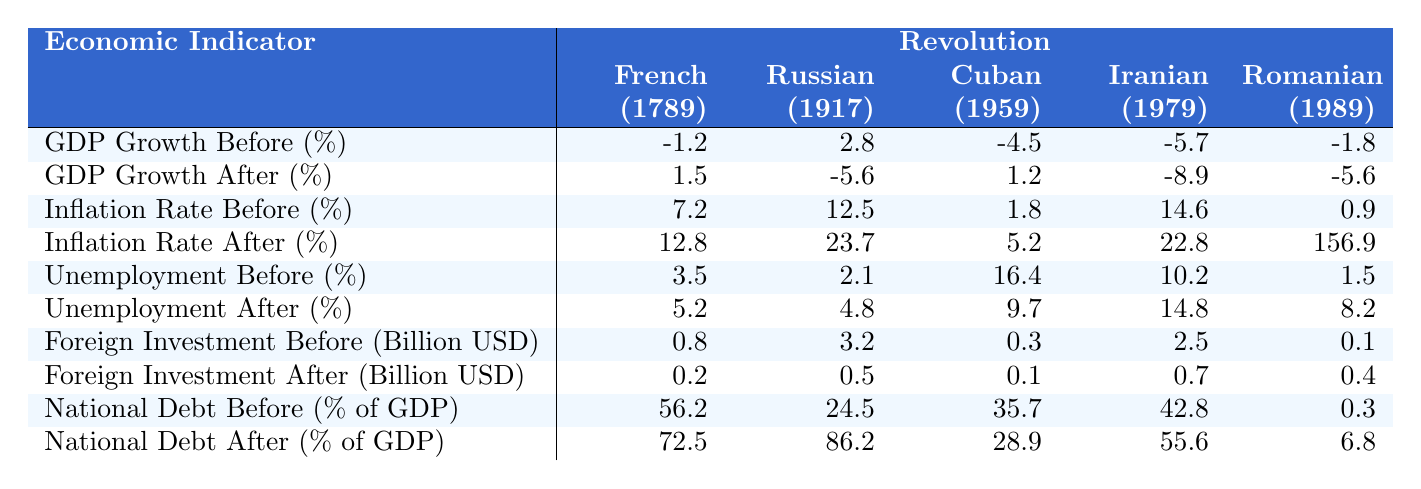What was the unemployment rate before the Cuban Revolution? The unemployment rate data for the Cuban Revolution (1959) is listed as 16.4%.
Answer: 16.4% What is the difference in GDP growth rates before and after the Iranian Revolution? For the Iranian Revolution (1979), GDP growth was -5.7% before and -8.9% after. The difference is calculated as -8.9 - (-5.7) = -3.2%.
Answer: -3.2% Was the inflation rate higher after the Romanian Revolution compared to before? The inflation rate before the Romanian Revolution (1989) was 0.9%, while after it was 156.9%. Since 156.9% is greater than 0.9%, the statement is true.
Answer: Yes Which revolution saw the highest increase in the national debt as a percentage of GDP? Examining the national debt before and after each revolution, the highest increase is from the Russian Revolution: it rose from 24.5% to 86.2%, a change of 61.7%.
Answer: Russian Revolution What was the average foreign investment in billion USD before all the revolutions? The foreign investments before the revolutions were 0.8, 3.2, 0.3, 2.5, and 0.1 billion USD. The average is calculated as (0.8 + 3.2 + 0.3 + 2.5 + 0.1) / 5 = 1.38 billion USD.
Answer: 1.38 billion USD How did the unemployment rate change in the aftermath of the French Revolution? The unemployment rate before the French Revolution (1789) was 3.5%, and it increased to 5.2% after. The change is 5.2% - 3.5% = 1.7%.
Answer: Increased by 1.7% Which revolution had the lowest foreign investment after its occurrence? The Cuban Revolution (1959) had 0.1 billion USD after, which is the lowest among all the listed revolutions.
Answer: Cuban Revolution How does the inflation rate after the Russian Revolution compare to that after the Iranian Revolution? The inflation rate after the Russian Revolution (23.7%) is greater than that after the Iranian Revolution (22.8%). Comparing these values shows that 23.7% > 22.8%.
Answer: 23.7% is greater What correlation can be observed between GDP growth before and after the revolutions? Comparing the GDP growth values, we can see that negative growth rates before most revolutions correlated with significantly negative growth or slight recoveries after, indicating a troubled economic landscape post-revolution. However, definitive correlation requires deeper analysis.
Answer: Correlation observed, mostly negative aftermath What was the total national debt as a percentage of GDP before the French and Romanian Revolutions? The national debt before the French Revolution was 56.2%, and before the Romanian Revolution, it was 0.3%. The total is 56.2% + 0.3% = 56.5%.
Answer: 56.5% 